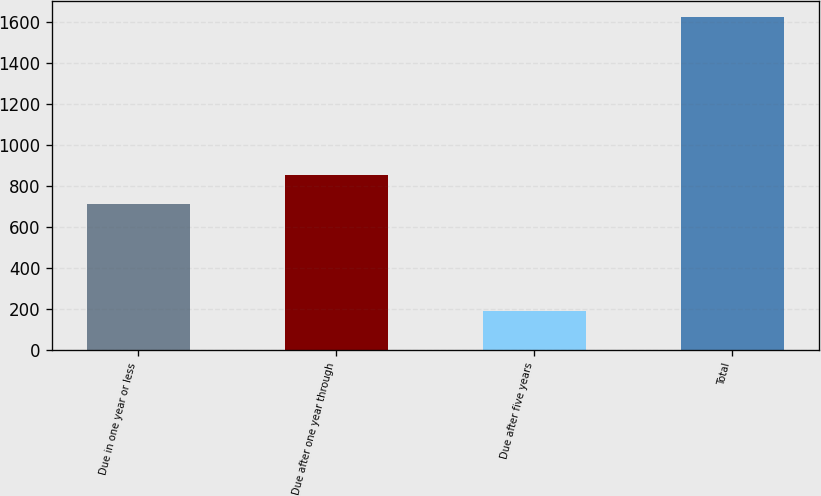Convert chart. <chart><loc_0><loc_0><loc_500><loc_500><bar_chart><fcel>Due in one year or less<fcel>Due after one year through<fcel>Due after five years<fcel>Total<nl><fcel>713<fcel>856.5<fcel>189.2<fcel>1624.2<nl></chart> 